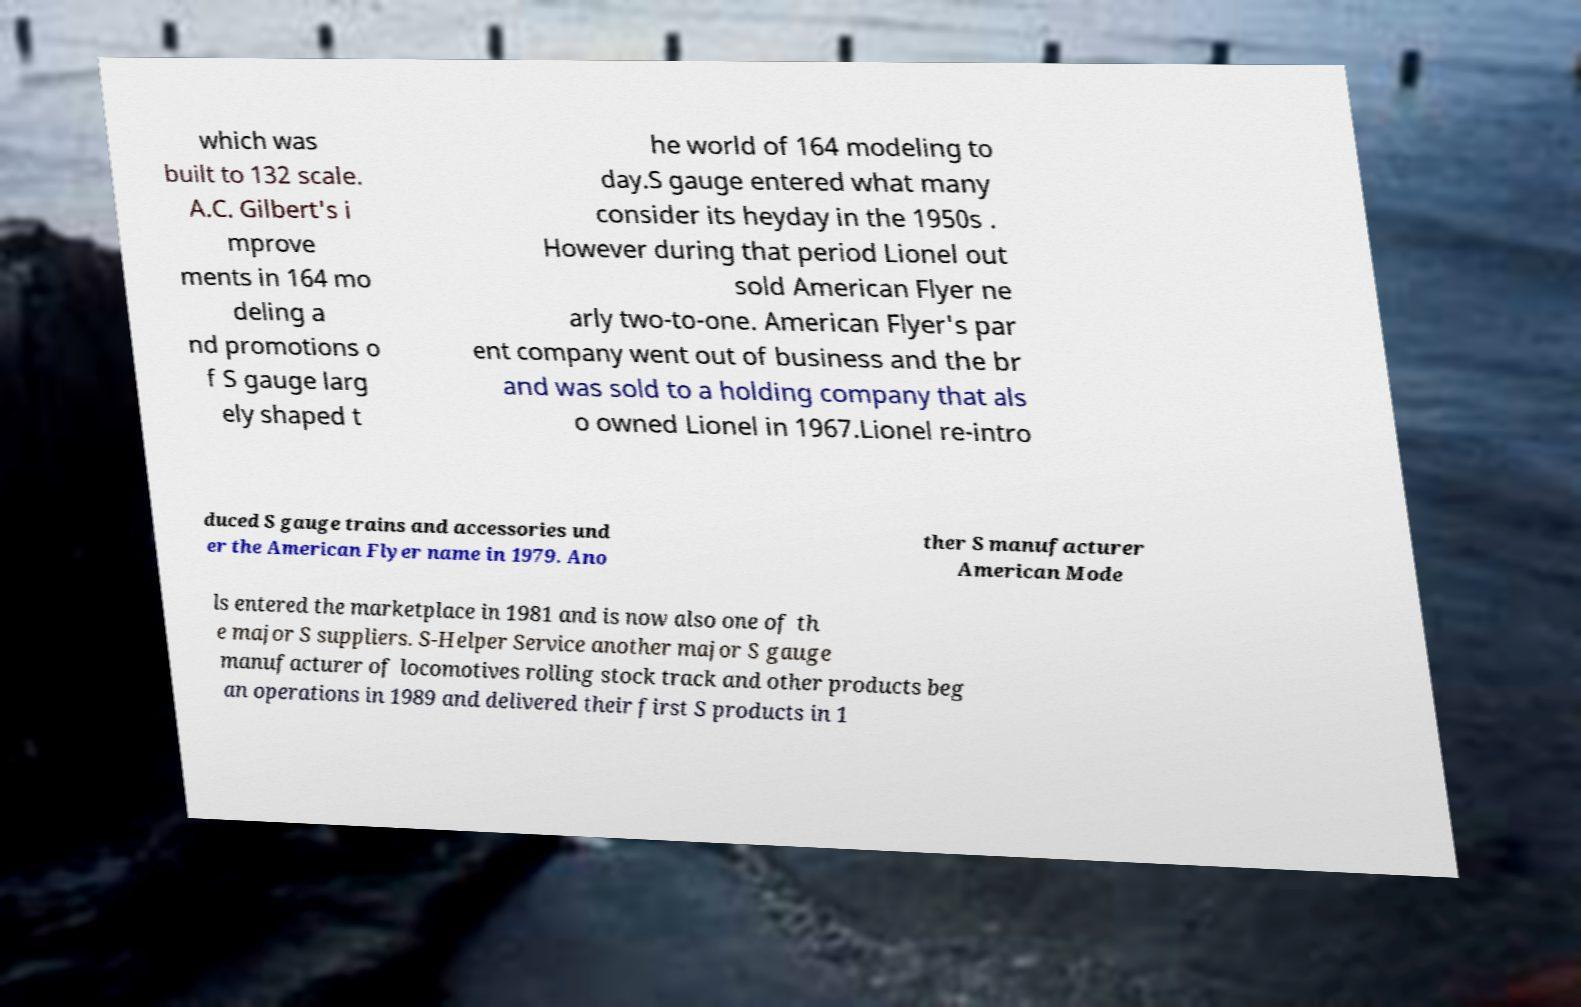Can you accurately transcribe the text from the provided image for me? which was built to 132 scale. A.C. Gilbert's i mprove ments in 164 mo deling a nd promotions o f S gauge larg ely shaped t he world of 164 modeling to day.S gauge entered what many consider its heyday in the 1950s . However during that period Lionel out sold American Flyer ne arly two-to-one. American Flyer's par ent company went out of business and the br and was sold to a holding company that als o owned Lionel in 1967.Lionel re-intro duced S gauge trains and accessories und er the American Flyer name in 1979. Ano ther S manufacturer American Mode ls entered the marketplace in 1981 and is now also one of th e major S suppliers. S-Helper Service another major S gauge manufacturer of locomotives rolling stock track and other products beg an operations in 1989 and delivered their first S products in 1 